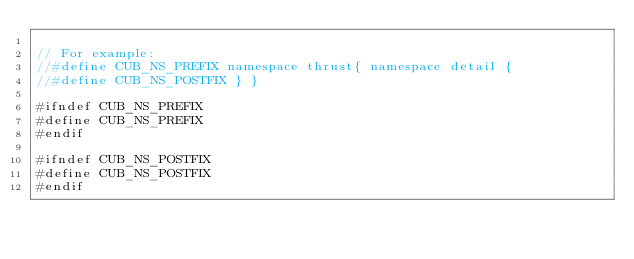<code> <loc_0><loc_0><loc_500><loc_500><_Cuda_>
// For example:
//#define CUB_NS_PREFIX namespace thrust{ namespace detail {
//#define CUB_NS_POSTFIX } }

#ifndef CUB_NS_PREFIX
#define CUB_NS_PREFIX
#endif

#ifndef CUB_NS_POSTFIX
#define CUB_NS_POSTFIX
#endif
</code> 